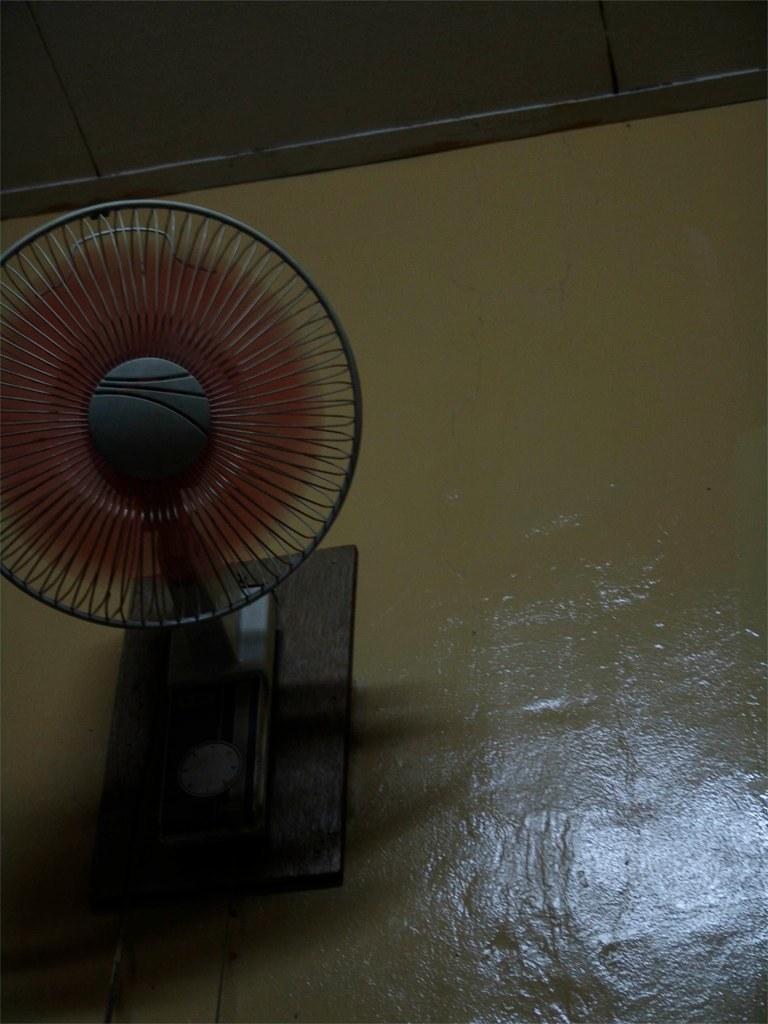Please provide a concise description of this image. On the left side of the image a fan, board are there. In the background of the image a wall is present. At the top of the image roof is there. 